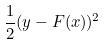Convert formula to latex. <formula><loc_0><loc_0><loc_500><loc_500>\frac { 1 } { 2 } ( y - F ( x ) ) ^ { 2 }</formula> 